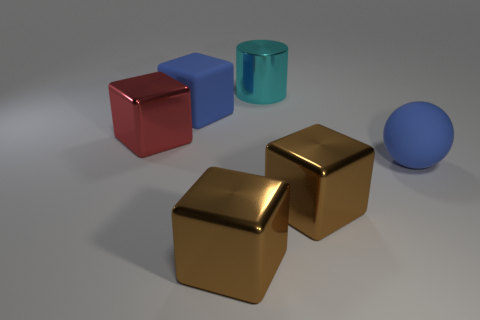How many large objects are either metal objects or red things?
Provide a short and direct response. 4. What shape is the big thing that is on the right side of the rubber block and behind the red shiny block?
Offer a very short reply. Cylinder. Do the cyan cylinder and the large red thing have the same material?
Make the answer very short. Yes. The sphere that is the same size as the blue rubber block is what color?
Your answer should be compact. Blue. The thing that is in front of the blue rubber sphere and on the left side of the cyan shiny cylinder is what color?
Make the answer very short. Brown. What size is the matte object that is the same color as the sphere?
Your answer should be very brief. Large. There is a rubber object that is the same color as the big rubber block; what is its shape?
Offer a terse response. Sphere. How big is the block right of the thing in front of the big block right of the big cyan metallic object?
Keep it short and to the point. Large. What is the material of the big blue sphere?
Ensure brevity in your answer.  Rubber. Is the material of the big cylinder the same as the big red object on the left side of the cyan cylinder?
Offer a terse response. Yes. 